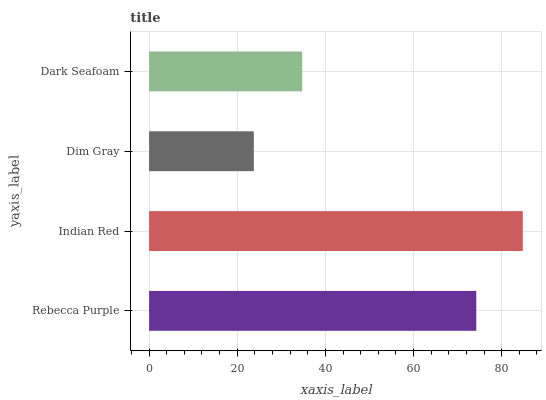Is Dim Gray the minimum?
Answer yes or no. Yes. Is Indian Red the maximum?
Answer yes or no. Yes. Is Indian Red the minimum?
Answer yes or no. No. Is Dim Gray the maximum?
Answer yes or no. No. Is Indian Red greater than Dim Gray?
Answer yes or no. Yes. Is Dim Gray less than Indian Red?
Answer yes or no. Yes. Is Dim Gray greater than Indian Red?
Answer yes or no. No. Is Indian Red less than Dim Gray?
Answer yes or no. No. Is Rebecca Purple the high median?
Answer yes or no. Yes. Is Dark Seafoam the low median?
Answer yes or no. Yes. Is Dark Seafoam the high median?
Answer yes or no. No. Is Indian Red the low median?
Answer yes or no. No. 